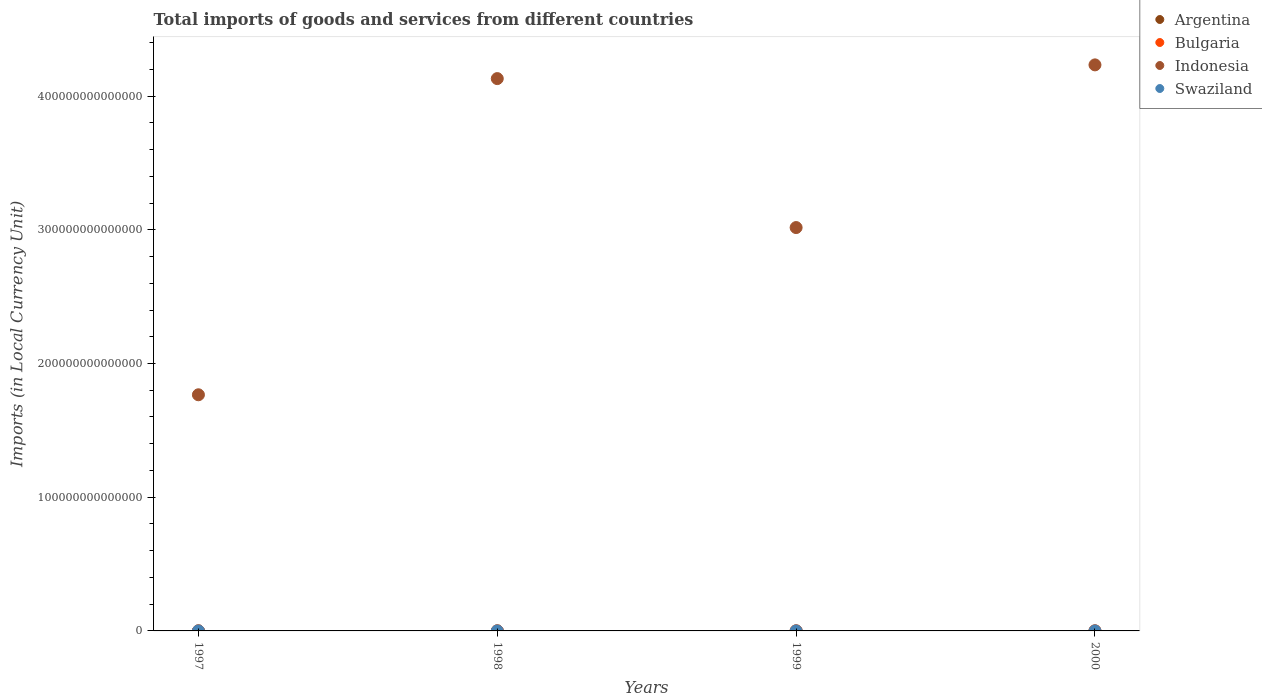How many different coloured dotlines are there?
Provide a short and direct response. 4. Is the number of dotlines equal to the number of legend labels?
Offer a terse response. Yes. What is the Amount of goods and services imports in Swaziland in 1997?
Your answer should be compact. 6.02e+09. Across all years, what is the maximum Amount of goods and services imports in Swaziland?
Offer a very short reply. 9.31e+09. Across all years, what is the minimum Amount of goods and services imports in Argentina?
Keep it short and to the point. 3.28e+1. In which year was the Amount of goods and services imports in Indonesia maximum?
Offer a very short reply. 2000. In which year was the Amount of goods and services imports in Bulgaria minimum?
Give a very brief answer. 1997. What is the total Amount of goods and services imports in Bulgaria in the graph?
Provide a short and direct response. 3.98e+1. What is the difference between the Amount of goods and services imports in Argentina in 1999 and that in 2000?
Offer a very short reply. -3.08e+08. What is the difference between the Amount of goods and services imports in Indonesia in 1998 and the Amount of goods and services imports in Argentina in 1999?
Offer a very short reply. 4.13e+14. What is the average Amount of goods and services imports in Bulgaria per year?
Your answer should be very brief. 9.96e+09. In the year 1999, what is the difference between the Amount of goods and services imports in Swaziland and Amount of goods and services imports in Indonesia?
Offer a very short reply. -3.02e+14. In how many years, is the Amount of goods and services imports in Bulgaria greater than 120000000000000 LCU?
Provide a succinct answer. 0. What is the ratio of the Amount of goods and services imports in Bulgaria in 1998 to that in 2000?
Offer a very short reply. 0.8. Is the difference between the Amount of goods and services imports in Swaziland in 1997 and 1998 greater than the difference between the Amount of goods and services imports in Indonesia in 1997 and 1998?
Provide a short and direct response. Yes. What is the difference between the highest and the second highest Amount of goods and services imports in Argentina?
Your answer should be very brief. 1.25e+09. What is the difference between the highest and the lowest Amount of goods and services imports in Swaziland?
Provide a short and direct response. 3.29e+09. In how many years, is the Amount of goods and services imports in Indonesia greater than the average Amount of goods and services imports in Indonesia taken over all years?
Offer a very short reply. 2. Is it the case that in every year, the sum of the Amount of goods and services imports in Argentina and Amount of goods and services imports in Bulgaria  is greater than the Amount of goods and services imports in Indonesia?
Ensure brevity in your answer.  No. Is the Amount of goods and services imports in Swaziland strictly greater than the Amount of goods and services imports in Indonesia over the years?
Offer a very short reply. No. What is the difference between two consecutive major ticks on the Y-axis?
Keep it short and to the point. 1.00e+14. How many legend labels are there?
Your response must be concise. 4. What is the title of the graph?
Offer a terse response. Total imports of goods and services from different countries. What is the label or title of the X-axis?
Provide a succinct answer. Years. What is the label or title of the Y-axis?
Provide a succinct answer. Imports (in Local Currency Unit). What is the Imports (in Local Currency Unit) in Argentina in 1997?
Your response must be concise. 3.74e+1. What is the Imports (in Local Currency Unit) of Bulgaria in 1997?
Your answer should be compact. 7.02e+09. What is the Imports (in Local Currency Unit) in Indonesia in 1997?
Provide a succinct answer. 1.77e+14. What is the Imports (in Local Currency Unit) of Swaziland in 1997?
Keep it short and to the point. 6.02e+09. What is the Imports (in Local Currency Unit) of Argentina in 1998?
Make the answer very short. 3.87e+1. What is the Imports (in Local Currency Unit) of Bulgaria in 1998?
Your answer should be very brief. 9.29e+09. What is the Imports (in Local Currency Unit) in Indonesia in 1998?
Make the answer very short. 4.13e+14. What is the Imports (in Local Currency Unit) of Swaziland in 1998?
Your response must be concise. 7.39e+09. What is the Imports (in Local Currency Unit) of Argentina in 1999?
Ensure brevity in your answer.  3.28e+1. What is the Imports (in Local Currency Unit) of Bulgaria in 1999?
Keep it short and to the point. 1.19e+1. What is the Imports (in Local Currency Unit) in Indonesia in 1999?
Offer a very short reply. 3.02e+14. What is the Imports (in Local Currency Unit) in Swaziland in 1999?
Provide a succinct answer. 7.69e+09. What is the Imports (in Local Currency Unit) in Argentina in 2000?
Make the answer very short. 3.31e+1. What is the Imports (in Local Currency Unit) of Bulgaria in 2000?
Keep it short and to the point. 1.17e+1. What is the Imports (in Local Currency Unit) of Indonesia in 2000?
Provide a short and direct response. 4.23e+14. What is the Imports (in Local Currency Unit) in Swaziland in 2000?
Your answer should be very brief. 9.31e+09. Across all years, what is the maximum Imports (in Local Currency Unit) of Argentina?
Keep it short and to the point. 3.87e+1. Across all years, what is the maximum Imports (in Local Currency Unit) of Bulgaria?
Give a very brief answer. 1.19e+1. Across all years, what is the maximum Imports (in Local Currency Unit) of Indonesia?
Give a very brief answer. 4.23e+14. Across all years, what is the maximum Imports (in Local Currency Unit) in Swaziland?
Offer a terse response. 9.31e+09. Across all years, what is the minimum Imports (in Local Currency Unit) in Argentina?
Your answer should be compact. 3.28e+1. Across all years, what is the minimum Imports (in Local Currency Unit) in Bulgaria?
Provide a succinct answer. 7.02e+09. Across all years, what is the minimum Imports (in Local Currency Unit) of Indonesia?
Your answer should be compact. 1.77e+14. Across all years, what is the minimum Imports (in Local Currency Unit) of Swaziland?
Keep it short and to the point. 6.02e+09. What is the total Imports (in Local Currency Unit) of Argentina in the graph?
Your answer should be compact. 1.42e+11. What is the total Imports (in Local Currency Unit) of Bulgaria in the graph?
Offer a terse response. 3.98e+1. What is the total Imports (in Local Currency Unit) of Indonesia in the graph?
Offer a very short reply. 1.31e+15. What is the total Imports (in Local Currency Unit) of Swaziland in the graph?
Ensure brevity in your answer.  3.04e+1. What is the difference between the Imports (in Local Currency Unit) of Argentina in 1997 and that in 1998?
Your response must be concise. -1.25e+09. What is the difference between the Imports (in Local Currency Unit) of Bulgaria in 1997 and that in 1998?
Give a very brief answer. -2.27e+09. What is the difference between the Imports (in Local Currency Unit) of Indonesia in 1997 and that in 1998?
Give a very brief answer. -2.36e+14. What is the difference between the Imports (in Local Currency Unit) of Swaziland in 1997 and that in 1998?
Make the answer very short. -1.37e+09. What is the difference between the Imports (in Local Currency Unit) of Argentina in 1997 and that in 1999?
Your answer should be compact. 4.65e+09. What is the difference between the Imports (in Local Currency Unit) of Bulgaria in 1997 and that in 1999?
Give a very brief answer. -4.83e+09. What is the difference between the Imports (in Local Currency Unit) in Indonesia in 1997 and that in 1999?
Your answer should be very brief. -1.25e+14. What is the difference between the Imports (in Local Currency Unit) of Swaziland in 1997 and that in 1999?
Provide a succinct answer. -1.66e+09. What is the difference between the Imports (in Local Currency Unit) in Argentina in 1997 and that in 2000?
Provide a succinct answer. 4.34e+09. What is the difference between the Imports (in Local Currency Unit) in Bulgaria in 1997 and that in 2000?
Provide a succinct answer. -4.66e+09. What is the difference between the Imports (in Local Currency Unit) of Indonesia in 1997 and that in 2000?
Your response must be concise. -2.47e+14. What is the difference between the Imports (in Local Currency Unit) in Swaziland in 1997 and that in 2000?
Offer a terse response. -3.29e+09. What is the difference between the Imports (in Local Currency Unit) in Argentina in 1998 and that in 1999?
Your response must be concise. 5.90e+09. What is the difference between the Imports (in Local Currency Unit) of Bulgaria in 1998 and that in 1999?
Offer a terse response. -2.56e+09. What is the difference between the Imports (in Local Currency Unit) in Indonesia in 1998 and that in 1999?
Provide a short and direct response. 1.11e+14. What is the difference between the Imports (in Local Currency Unit) in Swaziland in 1998 and that in 1999?
Provide a succinct answer. -2.95e+08. What is the difference between the Imports (in Local Currency Unit) of Argentina in 1998 and that in 2000?
Your answer should be very brief. 5.60e+09. What is the difference between the Imports (in Local Currency Unit) in Bulgaria in 1998 and that in 2000?
Offer a terse response. -2.39e+09. What is the difference between the Imports (in Local Currency Unit) of Indonesia in 1998 and that in 2000?
Your answer should be compact. -1.03e+13. What is the difference between the Imports (in Local Currency Unit) of Swaziland in 1998 and that in 2000?
Offer a very short reply. -1.92e+09. What is the difference between the Imports (in Local Currency Unit) of Argentina in 1999 and that in 2000?
Provide a succinct answer. -3.08e+08. What is the difference between the Imports (in Local Currency Unit) in Bulgaria in 1999 and that in 2000?
Make the answer very short. 1.72e+08. What is the difference between the Imports (in Local Currency Unit) of Indonesia in 1999 and that in 2000?
Offer a very short reply. -1.22e+14. What is the difference between the Imports (in Local Currency Unit) in Swaziland in 1999 and that in 2000?
Your answer should be very brief. -1.63e+09. What is the difference between the Imports (in Local Currency Unit) in Argentina in 1997 and the Imports (in Local Currency Unit) in Bulgaria in 1998?
Keep it short and to the point. 2.81e+1. What is the difference between the Imports (in Local Currency Unit) of Argentina in 1997 and the Imports (in Local Currency Unit) of Indonesia in 1998?
Offer a very short reply. -4.13e+14. What is the difference between the Imports (in Local Currency Unit) of Argentina in 1997 and the Imports (in Local Currency Unit) of Swaziland in 1998?
Ensure brevity in your answer.  3.00e+1. What is the difference between the Imports (in Local Currency Unit) in Bulgaria in 1997 and the Imports (in Local Currency Unit) in Indonesia in 1998?
Your response must be concise. -4.13e+14. What is the difference between the Imports (in Local Currency Unit) in Bulgaria in 1997 and the Imports (in Local Currency Unit) in Swaziland in 1998?
Make the answer very short. -3.70e+08. What is the difference between the Imports (in Local Currency Unit) of Indonesia in 1997 and the Imports (in Local Currency Unit) of Swaziland in 1998?
Provide a succinct answer. 1.77e+14. What is the difference between the Imports (in Local Currency Unit) of Argentina in 1997 and the Imports (in Local Currency Unit) of Bulgaria in 1999?
Keep it short and to the point. 2.56e+1. What is the difference between the Imports (in Local Currency Unit) of Argentina in 1997 and the Imports (in Local Currency Unit) of Indonesia in 1999?
Keep it short and to the point. -3.02e+14. What is the difference between the Imports (in Local Currency Unit) of Argentina in 1997 and the Imports (in Local Currency Unit) of Swaziland in 1999?
Provide a short and direct response. 2.97e+1. What is the difference between the Imports (in Local Currency Unit) in Bulgaria in 1997 and the Imports (in Local Currency Unit) in Indonesia in 1999?
Your answer should be very brief. -3.02e+14. What is the difference between the Imports (in Local Currency Unit) of Bulgaria in 1997 and the Imports (in Local Currency Unit) of Swaziland in 1999?
Your response must be concise. -6.65e+08. What is the difference between the Imports (in Local Currency Unit) of Indonesia in 1997 and the Imports (in Local Currency Unit) of Swaziland in 1999?
Provide a succinct answer. 1.77e+14. What is the difference between the Imports (in Local Currency Unit) in Argentina in 1997 and the Imports (in Local Currency Unit) in Bulgaria in 2000?
Keep it short and to the point. 2.57e+1. What is the difference between the Imports (in Local Currency Unit) in Argentina in 1997 and the Imports (in Local Currency Unit) in Indonesia in 2000?
Your answer should be very brief. -4.23e+14. What is the difference between the Imports (in Local Currency Unit) in Argentina in 1997 and the Imports (in Local Currency Unit) in Swaziland in 2000?
Your answer should be compact. 2.81e+1. What is the difference between the Imports (in Local Currency Unit) of Bulgaria in 1997 and the Imports (in Local Currency Unit) of Indonesia in 2000?
Ensure brevity in your answer.  -4.23e+14. What is the difference between the Imports (in Local Currency Unit) in Bulgaria in 1997 and the Imports (in Local Currency Unit) in Swaziland in 2000?
Ensure brevity in your answer.  -2.29e+09. What is the difference between the Imports (in Local Currency Unit) in Indonesia in 1997 and the Imports (in Local Currency Unit) in Swaziland in 2000?
Provide a succinct answer. 1.77e+14. What is the difference between the Imports (in Local Currency Unit) of Argentina in 1998 and the Imports (in Local Currency Unit) of Bulgaria in 1999?
Your answer should be compact. 2.68e+1. What is the difference between the Imports (in Local Currency Unit) in Argentina in 1998 and the Imports (in Local Currency Unit) in Indonesia in 1999?
Keep it short and to the point. -3.02e+14. What is the difference between the Imports (in Local Currency Unit) of Argentina in 1998 and the Imports (in Local Currency Unit) of Swaziland in 1999?
Offer a terse response. 3.10e+1. What is the difference between the Imports (in Local Currency Unit) in Bulgaria in 1998 and the Imports (in Local Currency Unit) in Indonesia in 1999?
Ensure brevity in your answer.  -3.02e+14. What is the difference between the Imports (in Local Currency Unit) of Bulgaria in 1998 and the Imports (in Local Currency Unit) of Swaziland in 1999?
Your answer should be compact. 1.60e+09. What is the difference between the Imports (in Local Currency Unit) in Indonesia in 1998 and the Imports (in Local Currency Unit) in Swaziland in 1999?
Make the answer very short. 4.13e+14. What is the difference between the Imports (in Local Currency Unit) in Argentina in 1998 and the Imports (in Local Currency Unit) in Bulgaria in 2000?
Keep it short and to the point. 2.70e+1. What is the difference between the Imports (in Local Currency Unit) in Argentina in 1998 and the Imports (in Local Currency Unit) in Indonesia in 2000?
Your answer should be very brief. -4.23e+14. What is the difference between the Imports (in Local Currency Unit) of Argentina in 1998 and the Imports (in Local Currency Unit) of Swaziland in 2000?
Your response must be concise. 2.94e+1. What is the difference between the Imports (in Local Currency Unit) of Bulgaria in 1998 and the Imports (in Local Currency Unit) of Indonesia in 2000?
Provide a succinct answer. -4.23e+14. What is the difference between the Imports (in Local Currency Unit) in Bulgaria in 1998 and the Imports (in Local Currency Unit) in Swaziland in 2000?
Make the answer very short. -2.32e+07. What is the difference between the Imports (in Local Currency Unit) in Indonesia in 1998 and the Imports (in Local Currency Unit) in Swaziland in 2000?
Your response must be concise. 4.13e+14. What is the difference between the Imports (in Local Currency Unit) of Argentina in 1999 and the Imports (in Local Currency Unit) of Bulgaria in 2000?
Give a very brief answer. 2.11e+1. What is the difference between the Imports (in Local Currency Unit) in Argentina in 1999 and the Imports (in Local Currency Unit) in Indonesia in 2000?
Offer a very short reply. -4.23e+14. What is the difference between the Imports (in Local Currency Unit) in Argentina in 1999 and the Imports (in Local Currency Unit) in Swaziland in 2000?
Offer a very short reply. 2.35e+1. What is the difference between the Imports (in Local Currency Unit) of Bulgaria in 1999 and the Imports (in Local Currency Unit) of Indonesia in 2000?
Your answer should be very brief. -4.23e+14. What is the difference between the Imports (in Local Currency Unit) in Bulgaria in 1999 and the Imports (in Local Currency Unit) in Swaziland in 2000?
Keep it short and to the point. 2.54e+09. What is the difference between the Imports (in Local Currency Unit) of Indonesia in 1999 and the Imports (in Local Currency Unit) of Swaziland in 2000?
Provide a short and direct response. 3.02e+14. What is the average Imports (in Local Currency Unit) in Argentina per year?
Provide a short and direct response. 3.55e+1. What is the average Imports (in Local Currency Unit) in Bulgaria per year?
Offer a very short reply. 9.96e+09. What is the average Imports (in Local Currency Unit) in Indonesia per year?
Make the answer very short. 3.29e+14. What is the average Imports (in Local Currency Unit) in Swaziland per year?
Make the answer very short. 7.60e+09. In the year 1997, what is the difference between the Imports (in Local Currency Unit) in Argentina and Imports (in Local Currency Unit) in Bulgaria?
Offer a terse response. 3.04e+1. In the year 1997, what is the difference between the Imports (in Local Currency Unit) of Argentina and Imports (in Local Currency Unit) of Indonesia?
Your answer should be very brief. -1.77e+14. In the year 1997, what is the difference between the Imports (in Local Currency Unit) in Argentina and Imports (in Local Currency Unit) in Swaziland?
Your response must be concise. 3.14e+1. In the year 1997, what is the difference between the Imports (in Local Currency Unit) in Bulgaria and Imports (in Local Currency Unit) in Indonesia?
Provide a short and direct response. -1.77e+14. In the year 1997, what is the difference between the Imports (in Local Currency Unit) of Bulgaria and Imports (in Local Currency Unit) of Swaziland?
Give a very brief answer. 9.97e+08. In the year 1997, what is the difference between the Imports (in Local Currency Unit) of Indonesia and Imports (in Local Currency Unit) of Swaziland?
Provide a succinct answer. 1.77e+14. In the year 1998, what is the difference between the Imports (in Local Currency Unit) in Argentina and Imports (in Local Currency Unit) in Bulgaria?
Provide a succinct answer. 2.94e+1. In the year 1998, what is the difference between the Imports (in Local Currency Unit) of Argentina and Imports (in Local Currency Unit) of Indonesia?
Ensure brevity in your answer.  -4.13e+14. In the year 1998, what is the difference between the Imports (in Local Currency Unit) in Argentina and Imports (in Local Currency Unit) in Swaziland?
Offer a terse response. 3.13e+1. In the year 1998, what is the difference between the Imports (in Local Currency Unit) of Bulgaria and Imports (in Local Currency Unit) of Indonesia?
Provide a short and direct response. -4.13e+14. In the year 1998, what is the difference between the Imports (in Local Currency Unit) in Bulgaria and Imports (in Local Currency Unit) in Swaziland?
Your answer should be compact. 1.90e+09. In the year 1998, what is the difference between the Imports (in Local Currency Unit) of Indonesia and Imports (in Local Currency Unit) of Swaziland?
Make the answer very short. 4.13e+14. In the year 1999, what is the difference between the Imports (in Local Currency Unit) in Argentina and Imports (in Local Currency Unit) in Bulgaria?
Your answer should be very brief. 2.09e+1. In the year 1999, what is the difference between the Imports (in Local Currency Unit) of Argentina and Imports (in Local Currency Unit) of Indonesia?
Give a very brief answer. -3.02e+14. In the year 1999, what is the difference between the Imports (in Local Currency Unit) of Argentina and Imports (in Local Currency Unit) of Swaziland?
Keep it short and to the point. 2.51e+1. In the year 1999, what is the difference between the Imports (in Local Currency Unit) in Bulgaria and Imports (in Local Currency Unit) in Indonesia?
Give a very brief answer. -3.02e+14. In the year 1999, what is the difference between the Imports (in Local Currency Unit) in Bulgaria and Imports (in Local Currency Unit) in Swaziland?
Keep it short and to the point. 4.17e+09. In the year 1999, what is the difference between the Imports (in Local Currency Unit) in Indonesia and Imports (in Local Currency Unit) in Swaziland?
Offer a very short reply. 3.02e+14. In the year 2000, what is the difference between the Imports (in Local Currency Unit) in Argentina and Imports (in Local Currency Unit) in Bulgaria?
Ensure brevity in your answer.  2.14e+1. In the year 2000, what is the difference between the Imports (in Local Currency Unit) of Argentina and Imports (in Local Currency Unit) of Indonesia?
Your answer should be compact. -4.23e+14. In the year 2000, what is the difference between the Imports (in Local Currency Unit) of Argentina and Imports (in Local Currency Unit) of Swaziland?
Provide a short and direct response. 2.38e+1. In the year 2000, what is the difference between the Imports (in Local Currency Unit) in Bulgaria and Imports (in Local Currency Unit) in Indonesia?
Make the answer very short. -4.23e+14. In the year 2000, what is the difference between the Imports (in Local Currency Unit) in Bulgaria and Imports (in Local Currency Unit) in Swaziland?
Keep it short and to the point. 2.37e+09. In the year 2000, what is the difference between the Imports (in Local Currency Unit) of Indonesia and Imports (in Local Currency Unit) of Swaziland?
Provide a succinct answer. 4.23e+14. What is the ratio of the Imports (in Local Currency Unit) of Argentina in 1997 to that in 1998?
Offer a terse response. 0.97. What is the ratio of the Imports (in Local Currency Unit) in Bulgaria in 1997 to that in 1998?
Offer a very short reply. 0.76. What is the ratio of the Imports (in Local Currency Unit) of Indonesia in 1997 to that in 1998?
Provide a succinct answer. 0.43. What is the ratio of the Imports (in Local Currency Unit) in Swaziland in 1997 to that in 1998?
Provide a short and direct response. 0.82. What is the ratio of the Imports (in Local Currency Unit) in Argentina in 1997 to that in 1999?
Your answer should be compact. 1.14. What is the ratio of the Imports (in Local Currency Unit) of Bulgaria in 1997 to that in 1999?
Ensure brevity in your answer.  0.59. What is the ratio of the Imports (in Local Currency Unit) in Indonesia in 1997 to that in 1999?
Offer a very short reply. 0.59. What is the ratio of the Imports (in Local Currency Unit) of Swaziland in 1997 to that in 1999?
Make the answer very short. 0.78. What is the ratio of the Imports (in Local Currency Unit) of Argentina in 1997 to that in 2000?
Make the answer very short. 1.13. What is the ratio of the Imports (in Local Currency Unit) in Bulgaria in 1997 to that in 2000?
Provide a short and direct response. 0.6. What is the ratio of the Imports (in Local Currency Unit) in Indonesia in 1997 to that in 2000?
Keep it short and to the point. 0.42. What is the ratio of the Imports (in Local Currency Unit) of Swaziland in 1997 to that in 2000?
Offer a very short reply. 0.65. What is the ratio of the Imports (in Local Currency Unit) in Argentina in 1998 to that in 1999?
Your answer should be very brief. 1.18. What is the ratio of the Imports (in Local Currency Unit) of Bulgaria in 1998 to that in 1999?
Provide a succinct answer. 0.78. What is the ratio of the Imports (in Local Currency Unit) in Indonesia in 1998 to that in 1999?
Make the answer very short. 1.37. What is the ratio of the Imports (in Local Currency Unit) in Swaziland in 1998 to that in 1999?
Ensure brevity in your answer.  0.96. What is the ratio of the Imports (in Local Currency Unit) of Argentina in 1998 to that in 2000?
Offer a very short reply. 1.17. What is the ratio of the Imports (in Local Currency Unit) of Bulgaria in 1998 to that in 2000?
Offer a very short reply. 0.8. What is the ratio of the Imports (in Local Currency Unit) in Indonesia in 1998 to that in 2000?
Keep it short and to the point. 0.98. What is the ratio of the Imports (in Local Currency Unit) of Swaziland in 1998 to that in 2000?
Your answer should be compact. 0.79. What is the ratio of the Imports (in Local Currency Unit) of Argentina in 1999 to that in 2000?
Make the answer very short. 0.99. What is the ratio of the Imports (in Local Currency Unit) in Bulgaria in 1999 to that in 2000?
Make the answer very short. 1.01. What is the ratio of the Imports (in Local Currency Unit) in Indonesia in 1999 to that in 2000?
Ensure brevity in your answer.  0.71. What is the ratio of the Imports (in Local Currency Unit) in Swaziland in 1999 to that in 2000?
Keep it short and to the point. 0.83. What is the difference between the highest and the second highest Imports (in Local Currency Unit) of Argentina?
Keep it short and to the point. 1.25e+09. What is the difference between the highest and the second highest Imports (in Local Currency Unit) in Bulgaria?
Provide a short and direct response. 1.72e+08. What is the difference between the highest and the second highest Imports (in Local Currency Unit) of Indonesia?
Keep it short and to the point. 1.03e+13. What is the difference between the highest and the second highest Imports (in Local Currency Unit) in Swaziland?
Give a very brief answer. 1.63e+09. What is the difference between the highest and the lowest Imports (in Local Currency Unit) of Argentina?
Make the answer very short. 5.90e+09. What is the difference between the highest and the lowest Imports (in Local Currency Unit) in Bulgaria?
Ensure brevity in your answer.  4.83e+09. What is the difference between the highest and the lowest Imports (in Local Currency Unit) of Indonesia?
Provide a succinct answer. 2.47e+14. What is the difference between the highest and the lowest Imports (in Local Currency Unit) of Swaziland?
Provide a short and direct response. 3.29e+09. 